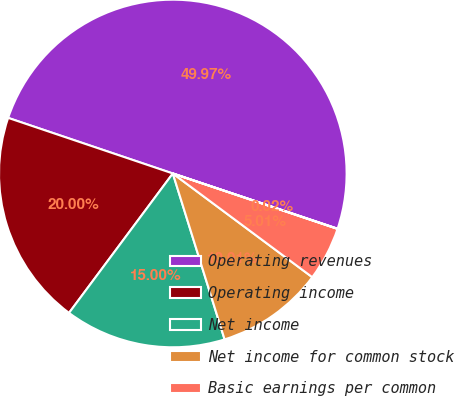<chart> <loc_0><loc_0><loc_500><loc_500><pie_chart><fcel>Operating revenues<fcel>Operating income<fcel>Net income<fcel>Net income for common stock<fcel>Basic earnings per common<fcel>Diluted earnings per common<nl><fcel>49.97%<fcel>20.0%<fcel>15.0%<fcel>10.01%<fcel>5.01%<fcel>0.02%<nl></chart> 